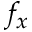<formula> <loc_0><loc_0><loc_500><loc_500>f _ { x }</formula> 